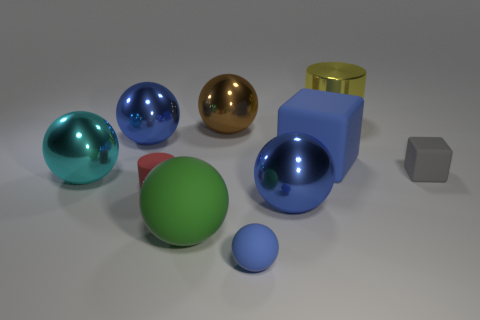Subtract all red cubes. How many blue spheres are left? 3 Subtract all cyan spheres. How many spheres are left? 5 Subtract all cyan shiny balls. How many balls are left? 5 Subtract 1 balls. How many balls are left? 5 Subtract all red balls. Subtract all red cylinders. How many balls are left? 6 Subtract all balls. How many objects are left? 4 Subtract all large matte things. Subtract all yellow things. How many objects are left? 7 Add 7 large blue shiny things. How many large blue shiny things are left? 9 Add 7 large rubber spheres. How many large rubber spheres exist? 8 Subtract 0 yellow blocks. How many objects are left? 10 